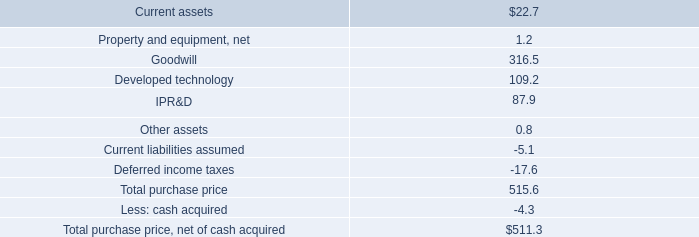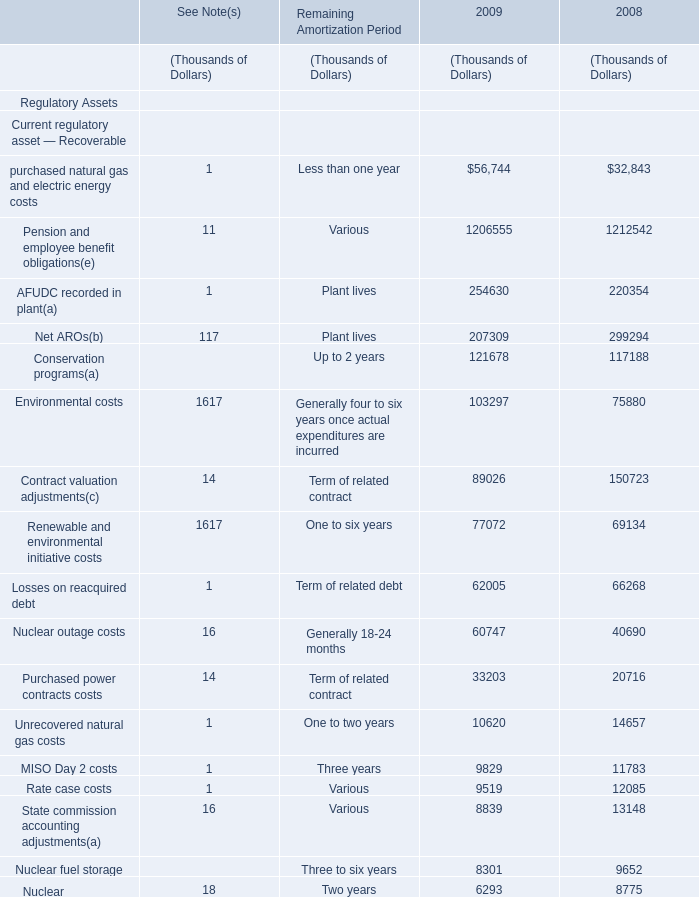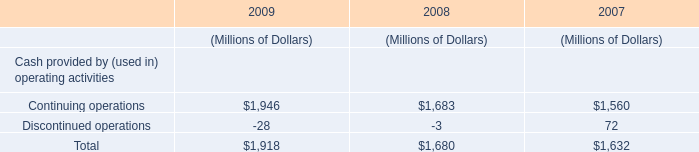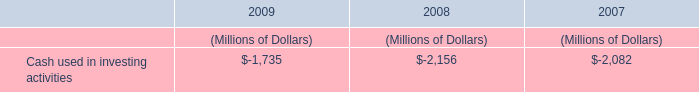In which year is the value of Total noncurrent regulatory assets smaller? 
Answer: 2009. 